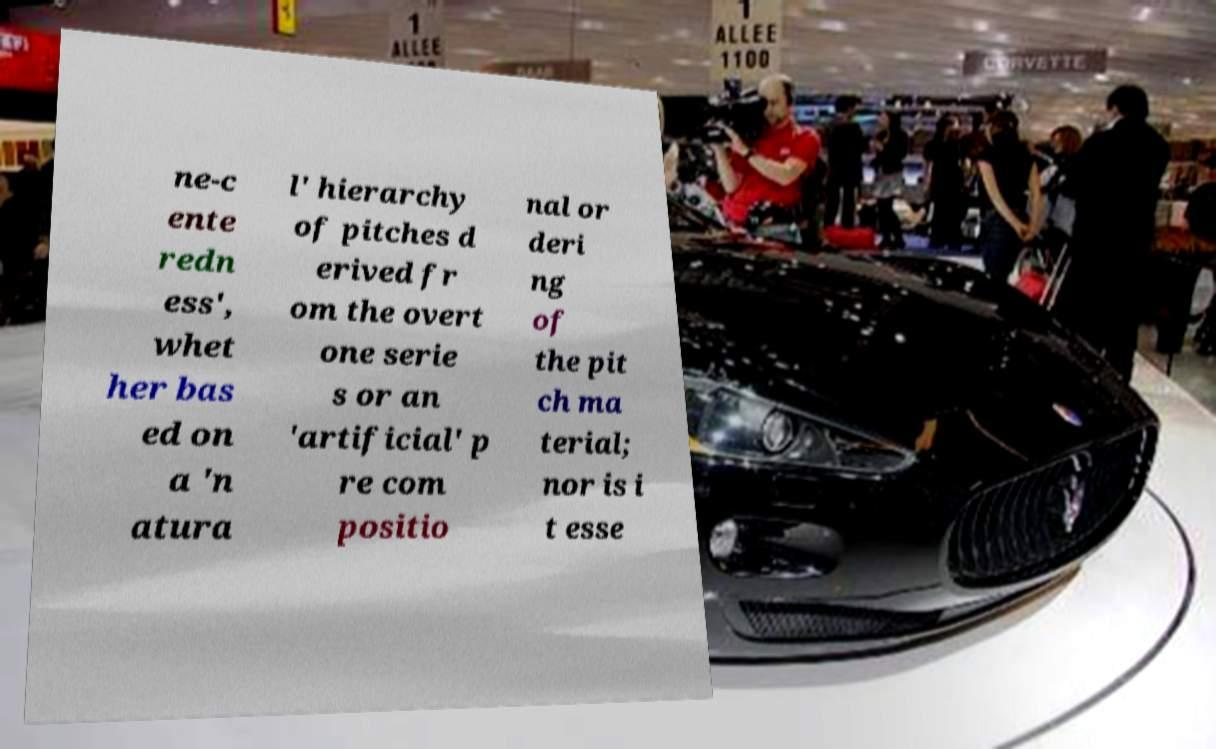There's text embedded in this image that I need extracted. Can you transcribe it verbatim? ne-c ente redn ess', whet her bas ed on a 'n atura l' hierarchy of pitches d erived fr om the overt one serie s or an 'artificial' p re com positio nal or deri ng of the pit ch ma terial; nor is i t esse 